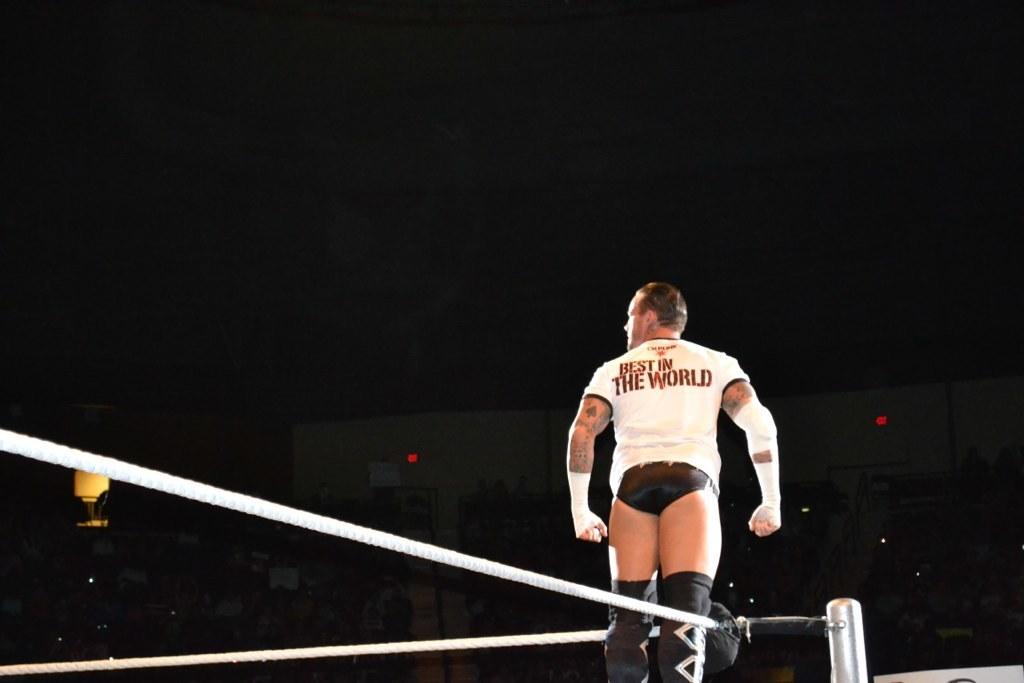What does it say on his shirt ?
Your answer should be compact. Best in the world. 